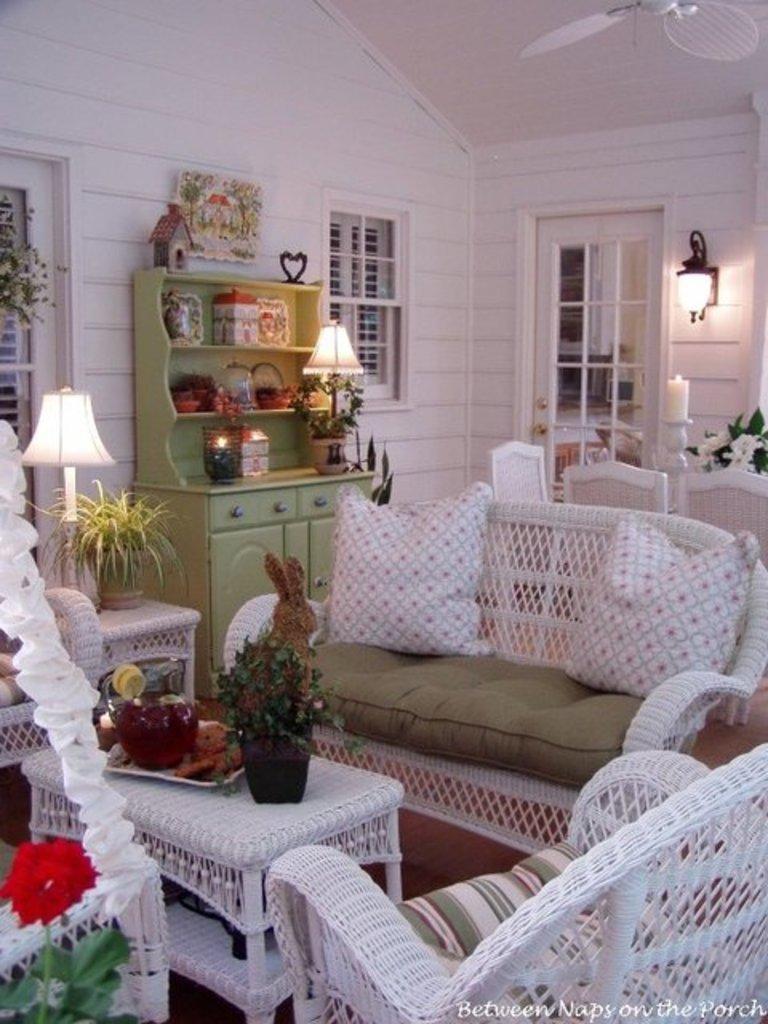Can you describe this image briefly? In this image there is a sofa having cushions. Before it there is a table having a tray and a pot. Pot is having a plant. The tray is having few objects on it. The table is surrounded by chairs. Left bottom there is a plant having a flower and leaves. Left side there is a chair. Bedside there is a table having a pot, lamp. Beside there is a cabinet having a lamp and few objects on it. Right side there are chairs. Behind there is a candle stand and a flower vase. A lamp is attached to the wall having a door and windows. Right to a fan is attached to the wall. 